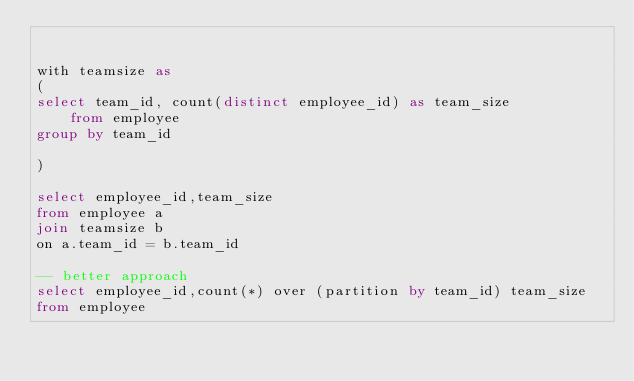<code> <loc_0><loc_0><loc_500><loc_500><_SQL_>

with teamsize as 
(
select team_id, count(distinct employee_id) as team_size
    from employee
group by team_id

)

select employee_id,team_size
from employee a
join teamsize b
on a.team_id = b.team_id

-- better approach
select employee_id,count(*) over (partition by team_id) team_size
from employee

</code> 